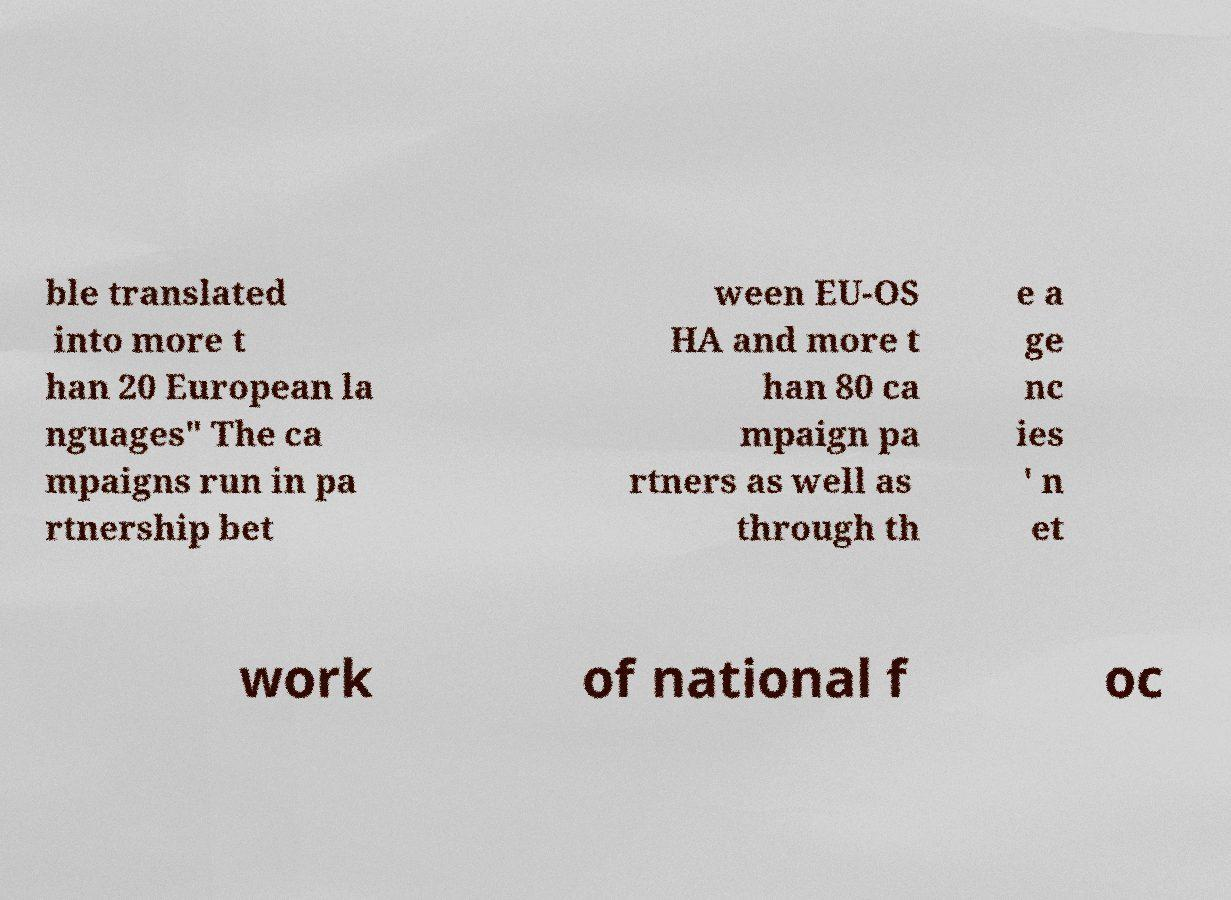Can you read and provide the text displayed in the image?This photo seems to have some interesting text. Can you extract and type it out for me? ble translated into more t han 20 European la nguages" The ca mpaigns run in pa rtnership bet ween EU-OS HA and more t han 80 ca mpaign pa rtners as well as through th e a ge nc ies ' n et work of national f oc 